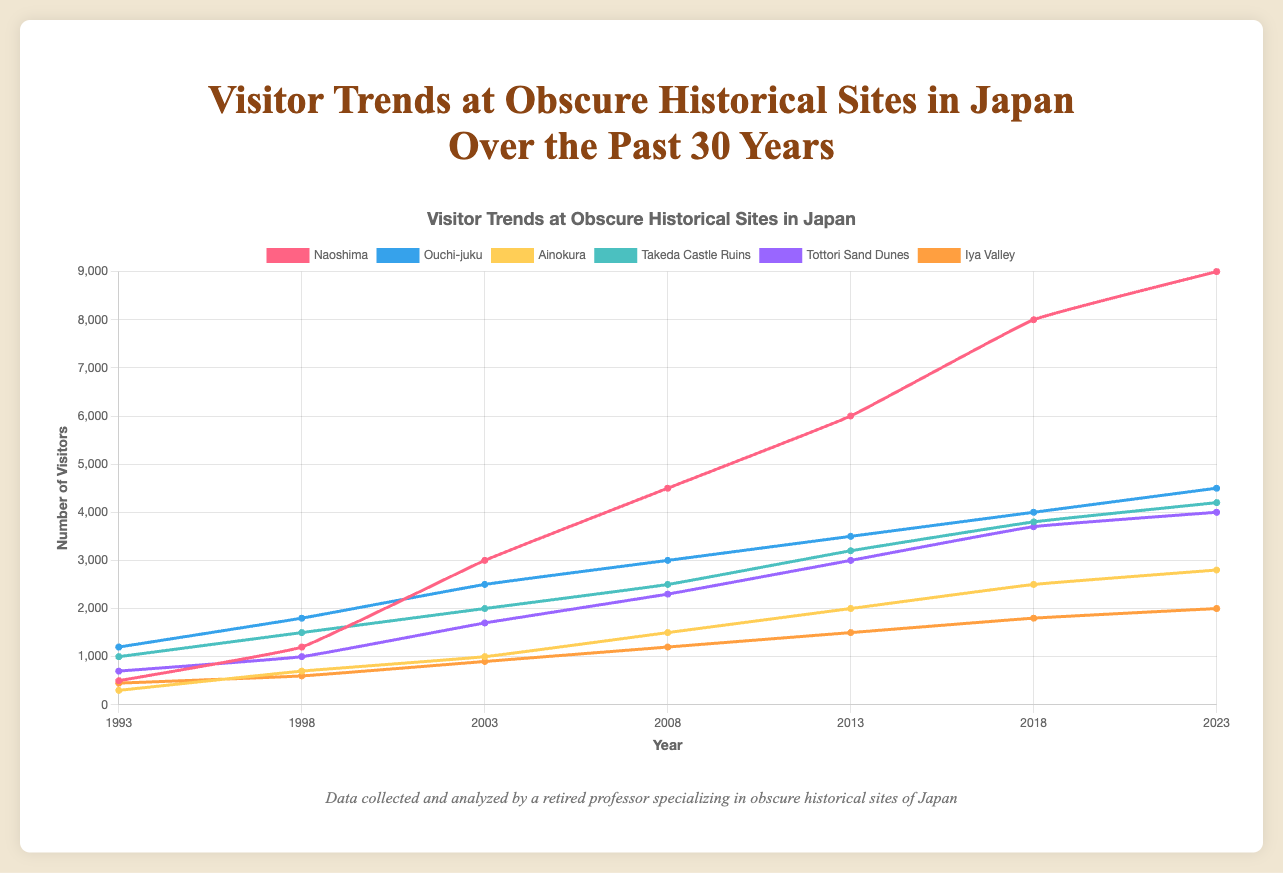What is the overall trend in the number of visitors to Naoshima from 1993 to 2023? The figure shows the number of visitors to Naoshima increasing consistently over the 30-year period, growing from 500 visitors in 1993 to 9000 in 2023.
Answer: Increasing trend Which historical site had the highest increase in the number of visitors between 1993 and 2023? To determine the highest increase, subtract the number of visitors in 1993 from the number of visitors in 2023 for each site. Naoshima had the highest increase: 9000 (2023) - 500 (1993) = 8500.
Answer: Naoshima Which historical site had the least number of visitors in 2008? Check the number of visitors for each site in 2008: Naoshima (4500), Ouchi-juku (3000), Ainokura (1500), Takeda Castle Ruins (2500), Tottori Sand Dunes (2300), Iya Valley (1200). Ainokura had the least number of visitors (1500).
Answer: Ainokura What is the difference in the number of visitors between Takeda Castle Ruins and Tottori Sand Dunes in 2018? Find the number of visitors for each site in 2018: Takeda Castle Ruins (3800), Tottori Sand Dunes (3700). The difference is 3800 - 3700 = 100.
Answer: 100 Which site had more visitors in 2023: Ouchi-juku or Iya Valley? Compare the number of visitors in 2023: Ouchi-juku (4500), Iya Valley (2000). Ouchi-juku had more visitors.
Answer: Ouchi-juku What is the proportional change in the number of visitors to Ainokura from 1993 to 2023? Calculate the proportional change using the formula: (final value - initial value) / initial value. For Ainokura: (2800 - 300) / 300 = 2500%.
Answer: 2500% Which sites experienced a plateau in the number of visitors from 2018 to 2023? Compare the number of visitors for each site between 2018 and 2023: Naoshima (8000 to 9000), Ouchi-juku (4000 to 4500), Ainokura (2500 to 2800), Takeda Castle Ruins (3800 to 4200), Tottori Sand Dunes (3700 to 4000), Iya Valley (1800 to 2000). All sites show an increase; none experienced a plateau.
Answer: None In which year did Naoshima surpass 3000 visitors? Look at the number of visitors for Naoshima across the years: it surpassed 3000 visitors in 2003.
Answer: 2003 Which site has consistently shown the smallest annual number of visitors over the 30-year period? Check the trends for each site: Ainokura consistently shows the smallest number of visitors over the years.
Answer: Ainokura What color is used for the line representing Tottori Sand Dunes in the figure? The line for Tottori Sand Dunes is represented in purple.
Answer: Purple 